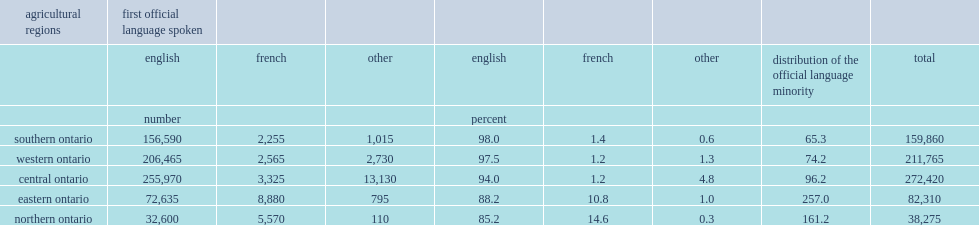In 2011, how many people aged 15 and older work in ontario's agri-food sector? 764630. What percent of people aged 15 and older work in ontario's agri-food sector were francophone? 0.02955. What percent of the province's agri-food workers aged 15 and older in 2011 are from eastern ontario? 0.107647. What percent of ontario's french-language workers are from eastern ontario? 0.393007. In 2011, what percent of the province's agri-food workers were from northern ontario? 0.050057. What percent of workers in northern ontario were francophone? 0.246515. 